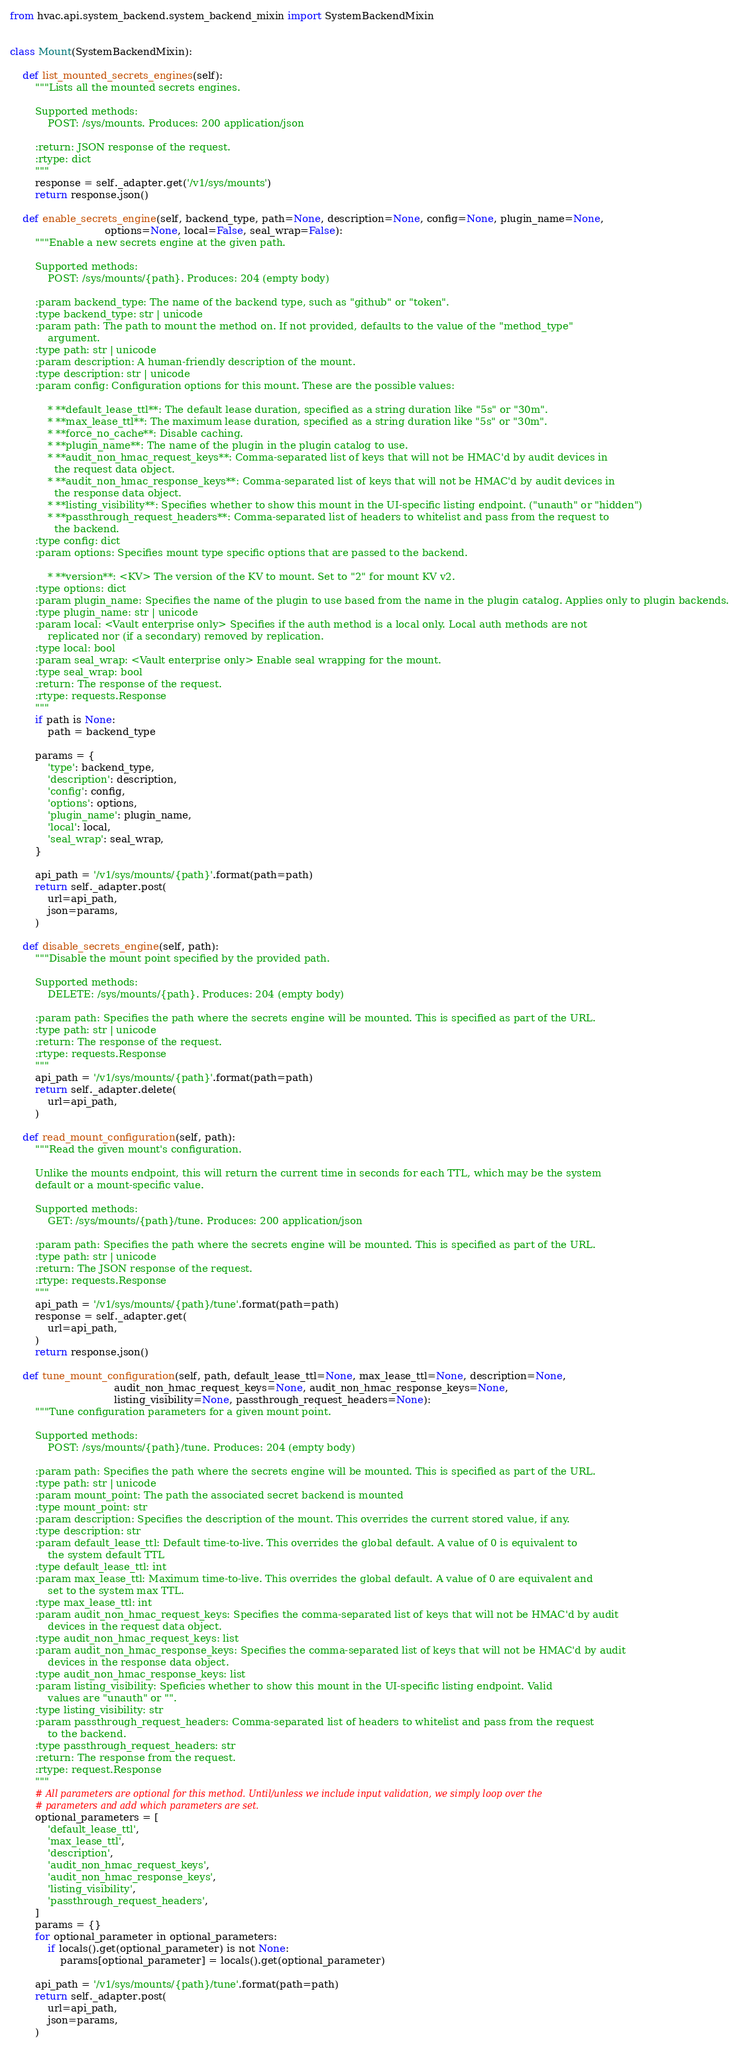Convert code to text. <code><loc_0><loc_0><loc_500><loc_500><_Python_>from hvac.api.system_backend.system_backend_mixin import SystemBackendMixin


class Mount(SystemBackendMixin):

    def list_mounted_secrets_engines(self):
        """Lists all the mounted secrets engines.

        Supported methods:
            POST: /sys/mounts. Produces: 200 application/json

        :return: JSON response of the request.
        :rtype: dict
        """
        response = self._adapter.get('/v1/sys/mounts')
        return response.json()

    def enable_secrets_engine(self, backend_type, path=None, description=None, config=None, plugin_name=None,
                              options=None, local=False, seal_wrap=False):
        """Enable a new secrets engine at the given path.

        Supported methods:
            POST: /sys/mounts/{path}. Produces: 204 (empty body)

        :param backend_type: The name of the backend type, such as "github" or "token".
        :type backend_type: str | unicode
        :param path: The path to mount the method on. If not provided, defaults to the value of the "method_type"
            argument.
        :type path: str | unicode
        :param description: A human-friendly description of the mount.
        :type description: str | unicode
        :param config: Configuration options for this mount. These are the possible values:

            * **default_lease_ttl**: The default lease duration, specified as a string duration like "5s" or "30m".
            * **max_lease_ttl**: The maximum lease duration, specified as a string duration like "5s" or "30m".
            * **force_no_cache**: Disable caching.
            * **plugin_name**: The name of the plugin in the plugin catalog to use.
            * **audit_non_hmac_request_keys**: Comma-separated list of keys that will not be HMAC'd by audit devices in
              the request data object.
            * **audit_non_hmac_response_keys**: Comma-separated list of keys that will not be HMAC'd by audit devices in
              the response data object.
            * **listing_visibility**: Specifies whether to show this mount in the UI-specific listing endpoint. ("unauth" or "hidden")
            * **passthrough_request_headers**: Comma-separated list of headers to whitelist and pass from the request to
              the backend.
        :type config: dict
        :param options: Specifies mount type specific options that are passed to the backend.

            * **version**: <KV> The version of the KV to mount. Set to "2" for mount KV v2.
        :type options: dict
        :param plugin_name: Specifies the name of the plugin to use based from the name in the plugin catalog. Applies only to plugin backends.
        :type plugin_name: str | unicode
        :param local: <Vault enterprise only> Specifies if the auth method is a local only. Local auth methods are not
            replicated nor (if a secondary) removed by replication.
        :type local: bool
        :param seal_wrap: <Vault enterprise only> Enable seal wrapping for the mount.
        :type seal_wrap: bool
        :return: The response of the request.
        :rtype: requests.Response
        """
        if path is None:
            path = backend_type

        params = {
            'type': backend_type,
            'description': description,
            'config': config,
            'options': options,
            'plugin_name': plugin_name,
            'local': local,
            'seal_wrap': seal_wrap,
        }

        api_path = '/v1/sys/mounts/{path}'.format(path=path)
        return self._adapter.post(
            url=api_path,
            json=params,
        )

    def disable_secrets_engine(self, path):
        """Disable the mount point specified by the provided path.

        Supported methods:
            DELETE: /sys/mounts/{path}. Produces: 204 (empty body)

        :param path: Specifies the path where the secrets engine will be mounted. This is specified as part of the URL.
        :type path: str | unicode
        :return: The response of the request.
        :rtype: requests.Response
        """
        api_path = '/v1/sys/mounts/{path}'.format(path=path)
        return self._adapter.delete(
            url=api_path,
        )

    def read_mount_configuration(self, path):
        """Read the given mount's configuration.

        Unlike the mounts endpoint, this will return the current time in seconds for each TTL, which may be the system
        default or a mount-specific value.

        Supported methods:
            GET: /sys/mounts/{path}/tune. Produces: 200 application/json

        :param path: Specifies the path where the secrets engine will be mounted. This is specified as part of the URL.
        :type path: str | unicode
        :return: The JSON response of the request.
        :rtype: requests.Response
        """
        api_path = '/v1/sys/mounts/{path}/tune'.format(path=path)
        response = self._adapter.get(
            url=api_path,
        )
        return response.json()

    def tune_mount_configuration(self, path, default_lease_ttl=None, max_lease_ttl=None, description=None,
                                 audit_non_hmac_request_keys=None, audit_non_hmac_response_keys=None,
                                 listing_visibility=None, passthrough_request_headers=None):
        """Tune configuration parameters for a given mount point.

        Supported methods:
            POST: /sys/mounts/{path}/tune. Produces: 204 (empty body)

        :param path: Specifies the path where the secrets engine will be mounted. This is specified as part of the URL.
        :type path: str | unicode
        :param mount_point: The path the associated secret backend is mounted
        :type mount_point: str
        :param description: Specifies the description of the mount. This overrides the current stored value, if any.
        :type description: str
        :param default_lease_ttl: Default time-to-live. This overrides the global default. A value of 0 is equivalent to
            the system default TTL
        :type default_lease_ttl: int
        :param max_lease_ttl: Maximum time-to-live. This overrides the global default. A value of 0 are equivalent and
            set to the system max TTL.
        :type max_lease_ttl: int
        :param audit_non_hmac_request_keys: Specifies the comma-separated list of keys that will not be HMAC'd by audit
            devices in the request data object.
        :type audit_non_hmac_request_keys: list
        :param audit_non_hmac_response_keys: Specifies the comma-separated list of keys that will not be HMAC'd by audit
            devices in the response data object.
        :type audit_non_hmac_response_keys: list
        :param listing_visibility: Speficies whether to show this mount in the UI-specific listing endpoint. Valid
            values are "unauth" or "".
        :type listing_visibility: str
        :param passthrough_request_headers: Comma-separated list of headers to whitelist and pass from the request
            to the backend.
        :type passthrough_request_headers: str
        :return: The response from the request.
        :rtype: request.Response
        """
        # All parameters are optional for this method. Until/unless we include input validation, we simply loop over the
        # parameters and add which parameters are set.
        optional_parameters = [
            'default_lease_ttl',
            'max_lease_ttl',
            'description',
            'audit_non_hmac_request_keys',
            'audit_non_hmac_response_keys',
            'listing_visibility',
            'passthrough_request_headers',
        ]
        params = {}
        for optional_parameter in optional_parameters:
            if locals().get(optional_parameter) is not None:
                params[optional_parameter] = locals().get(optional_parameter)

        api_path = '/v1/sys/mounts/{path}/tune'.format(path=path)
        return self._adapter.post(
            url=api_path,
            json=params,
        )
</code> 